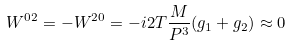Convert formula to latex. <formula><loc_0><loc_0><loc_500><loc_500>W ^ { 0 2 } = - W ^ { 2 0 } = - i 2 T \frac { M } { P ^ { 3 } } ( g _ { 1 } + g _ { 2 } ) \approx 0</formula> 